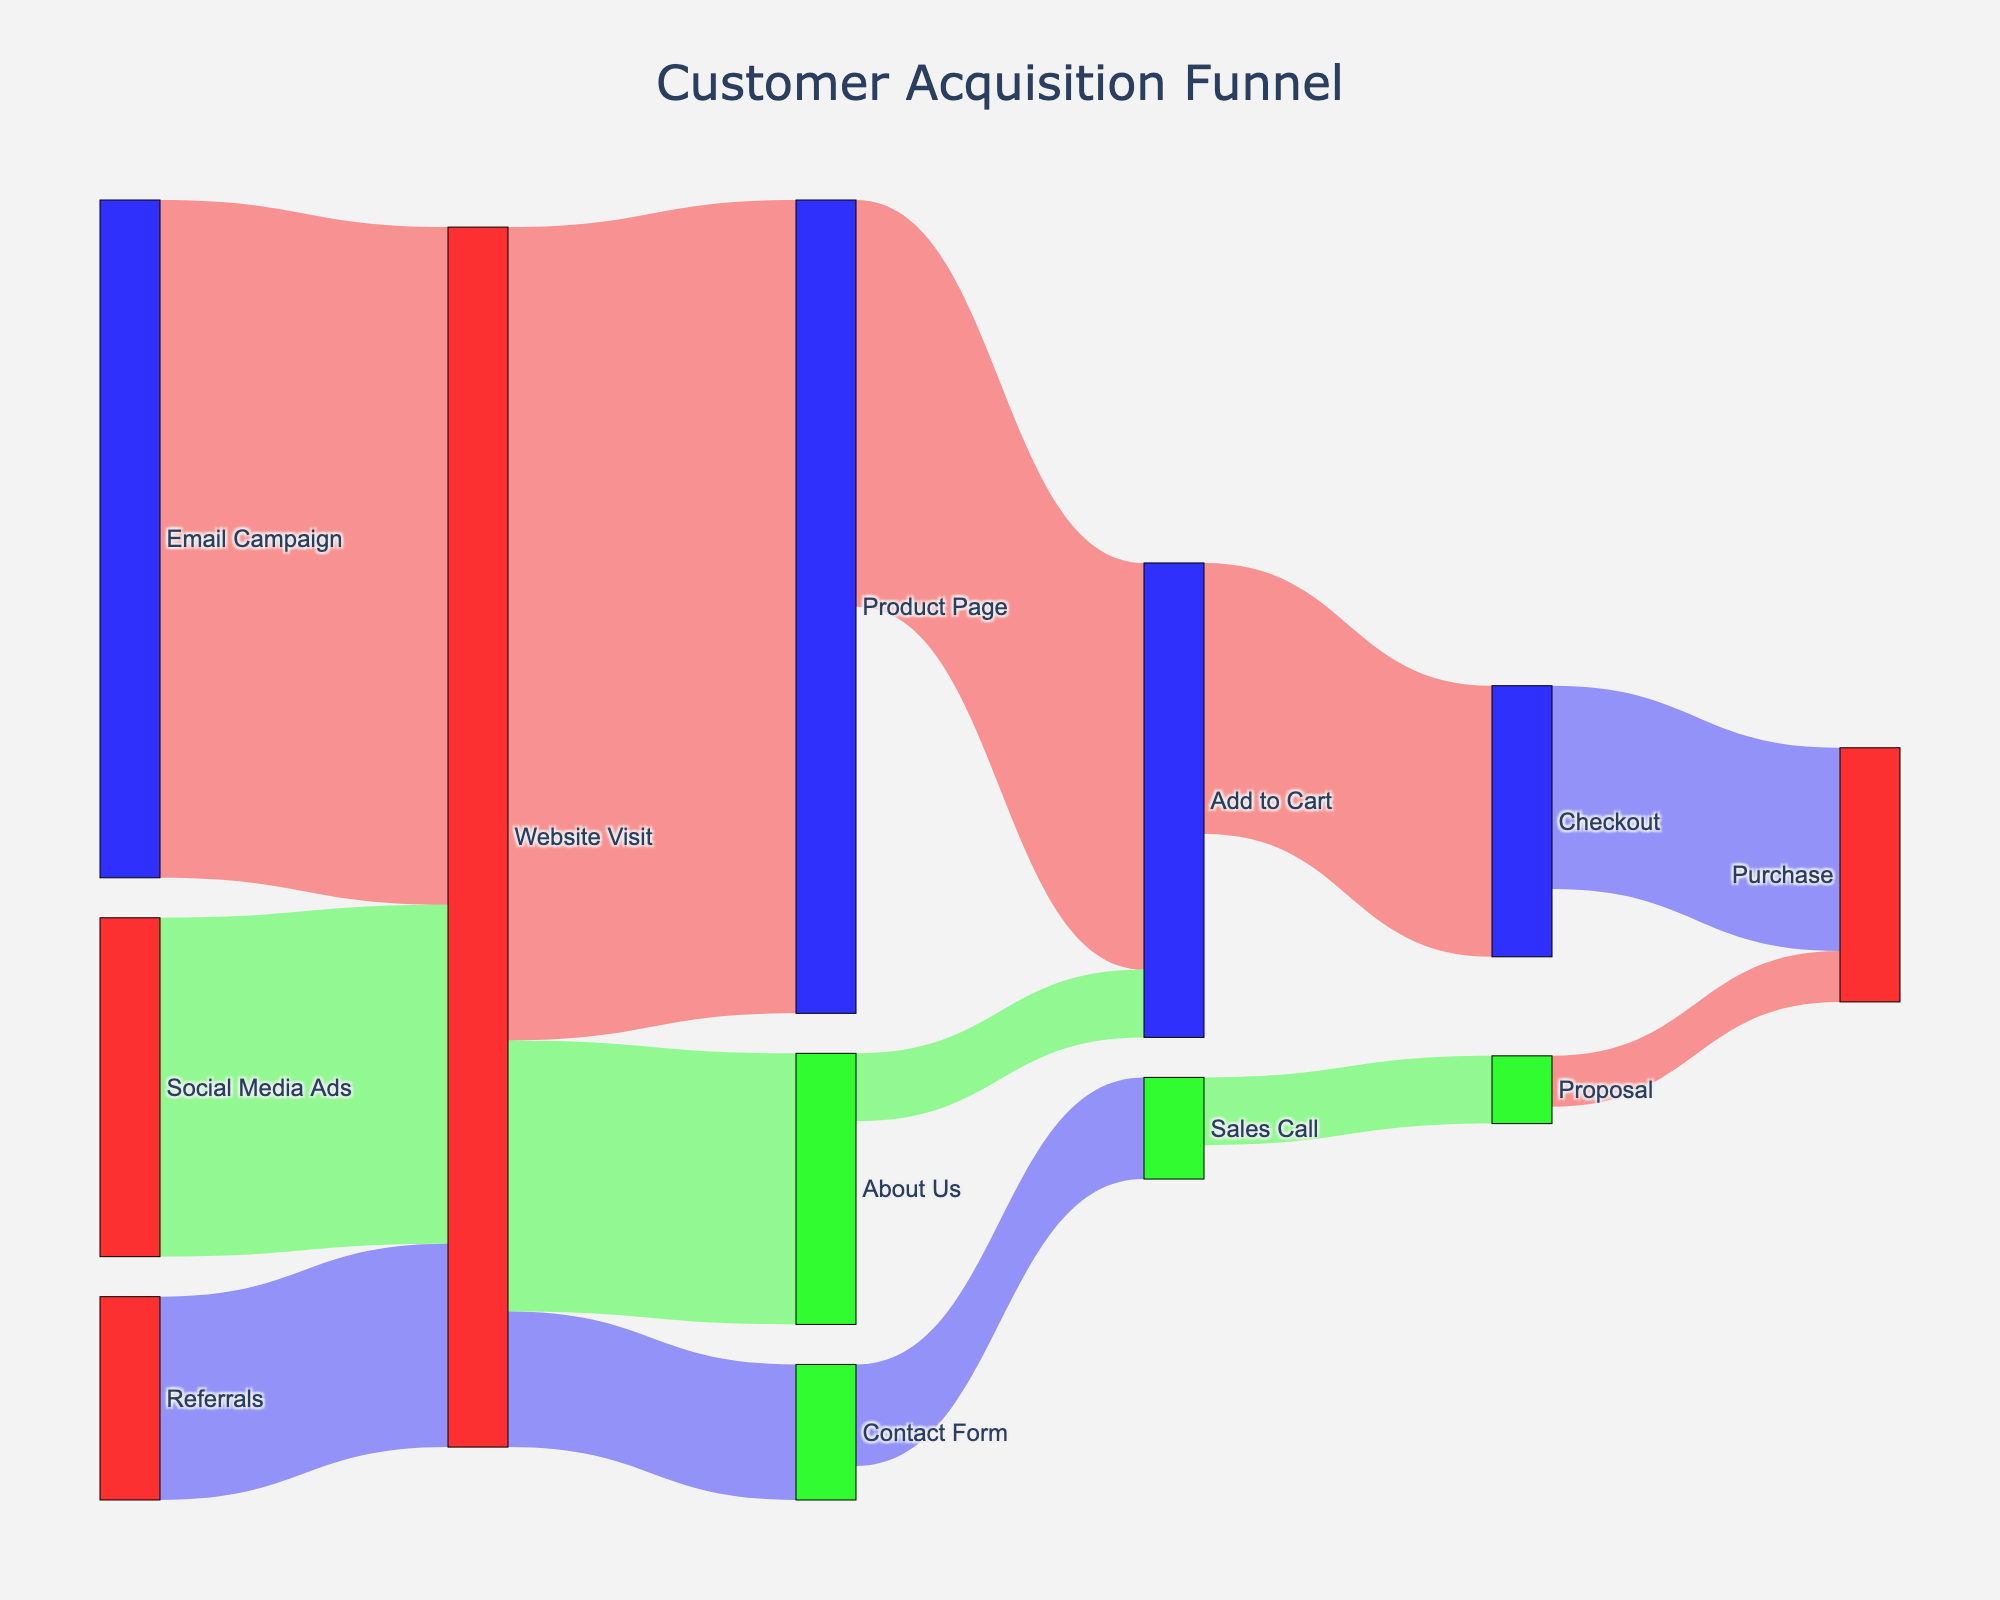What is the title of the diagram? The title is usually located at the top of the diagram and states the main focus of the diagram.
Answer: Customer Acquisition Funnel What are the initial sources of customer contact in the funnel? Initial sources refer to the elements from which the first connections originate. These are identified as the standalone starting points in the leftmost column of the diagram.
Answer: Email Campaign, Social Media Ads, Referrals How many customers visited the website from the Email Campaign? The width of the link connecting 'Email Campaign' and 'Website Visit' visually represents the flow value, which is also labeled.
Answer: 1000 Which customer acquisition source generated the least visits to the website? Compare the values of the links connecting 'Email Campaign', 'Social Media Ads', and 'Referrals' to 'Website Visit'. The link with the smallest value indicates the source with the least visits.
Answer: Referrals How many people progressed from the product page to the checkout? Look at the link that connects 'Product Page' to 'Add to Cart' and then 'Add to Cart' to 'Checkout' and sum the values if necessary.
Answer: 400 Which transition represents the highest drop-off in customer numbers? Identify where the flow value significantly decreases when moving from one node to another. The visual comparison of link widths helps in determining this.
Answer: Website Visit to About Us (1200 to 400) What is the total number of purchases made at the end of the funnel? Sum the values of all links leading to 'Purchase'. This includes links from 'Checkout' and 'Proposal'.
Answer: 375 How many customers showed interest enough to initiate a sales call through the contact form? Identify the width of the link connecting 'Contact Form' to 'Sales Call.'
Answer: 150 What proportion of website visitors proceeded to the product page compared to those who visited the about us page? Compare the number of customers moving from 'Website Visit' to 'Product Page' with those moving from 'Website Visit' to 'About Us'. Use their respective values to calculate the ratio.
Answer: 1200 to 400, or 3:1 Which pathway shows more conversions to purchases, direct checkout after adding to cart or via proposal after a sales call? Compare the values of the links 'Checkout' to 'Purchase' and 'Proposal' to 'Purchase'.
Answer: Direct Checkout (300 vs. 75) 